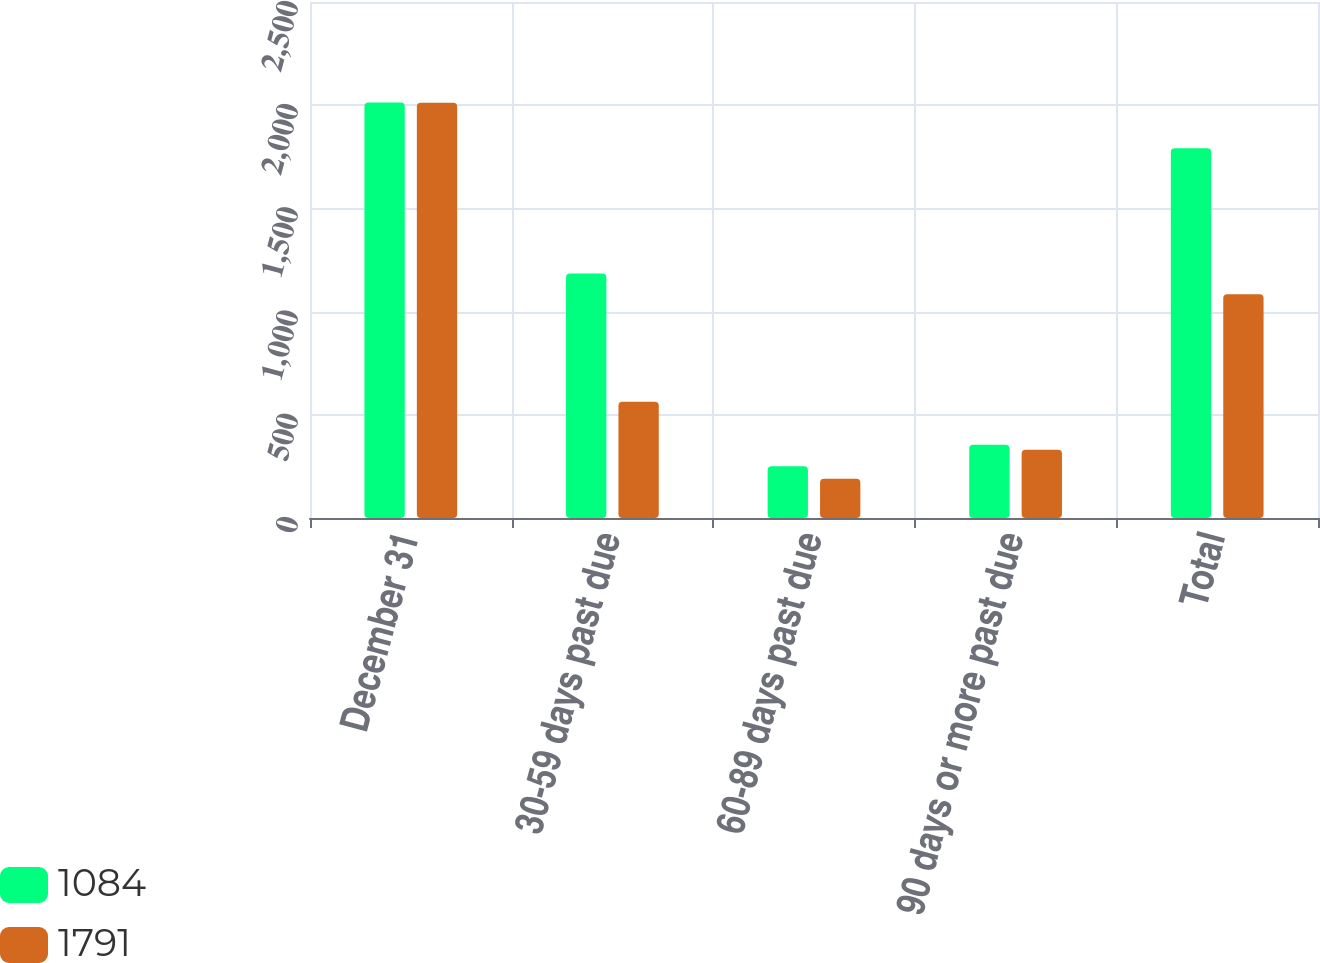Convert chart to OTSL. <chart><loc_0><loc_0><loc_500><loc_500><stacked_bar_chart><ecel><fcel>December 31<fcel>30-59 days past due<fcel>60-89 days past due<fcel>90 days or more past due<fcel>Total<nl><fcel>1084<fcel>2013<fcel>1185<fcel>251<fcel>355<fcel>1791<nl><fcel>1791<fcel>2012<fcel>563<fcel>190<fcel>331<fcel>1084<nl></chart> 